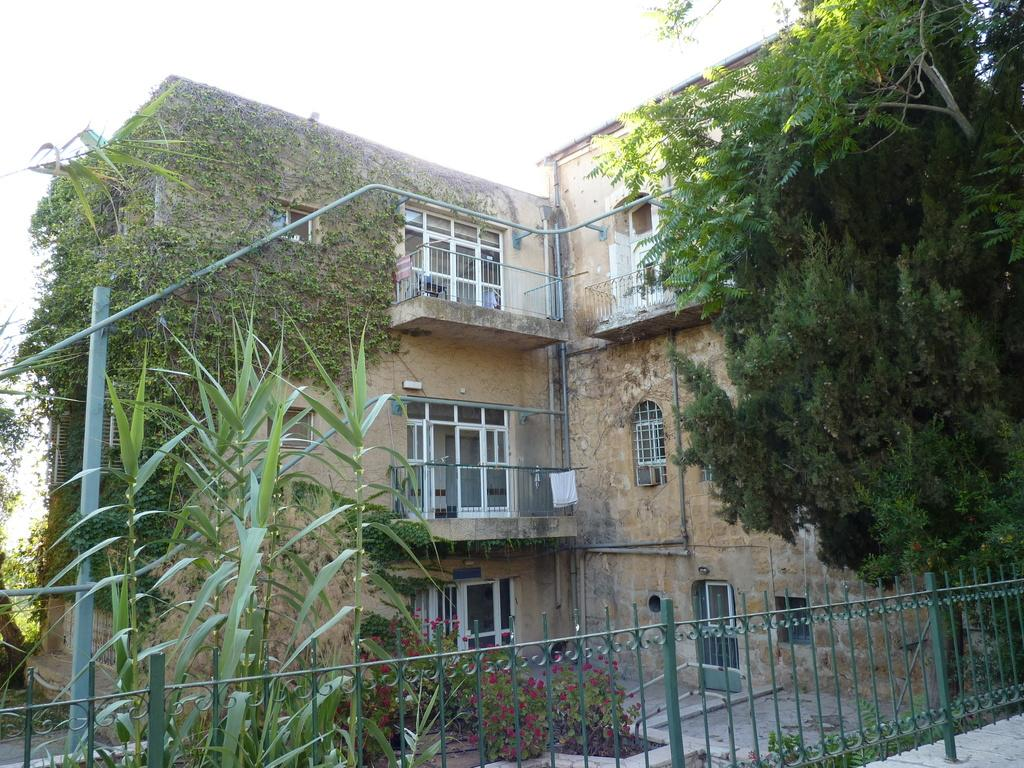What type of structure is visible in the image? There is a building in the image. What is growing on the building? Creeper plants are present on the building. What other types of vegetation can be seen in the image? There are trees and plants with flowers in the image. What is in front of the building? There is an iron railing in front of the building. How does the building express its opinion about the trees in the image? Buildings do not have opinions, as they are inanimate objects. The image simply shows a building with creeper plants, trees, and plants with flowers. 